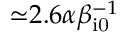Convert formula to latex. <formula><loc_0><loc_0><loc_500><loc_500>{ \simeq } 2 . 6 \alpha \beta _ { i 0 } ^ { - 1 }</formula> 